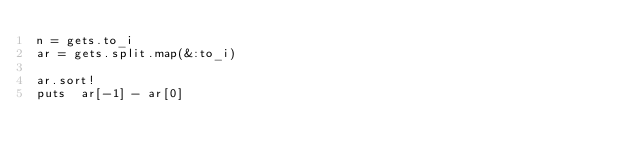<code> <loc_0><loc_0><loc_500><loc_500><_Ruby_>n = gets.to_i
ar = gets.split.map(&:to_i)

ar.sort!
puts  ar[-1] - ar[0]
</code> 